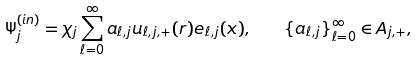<formula> <loc_0><loc_0><loc_500><loc_500>\Psi _ { j } ^ { ( i n ) } = \chi _ { j } \sum _ { \ell = 0 } ^ { \infty } a _ { \ell , j } u _ { \ell , j , + } ( r ) e _ { \ell , j } ( x ) , \quad \{ a _ { \ell , j } \} _ { \ell = 0 } ^ { \infty } \in { A } _ { j , + } ,</formula> 